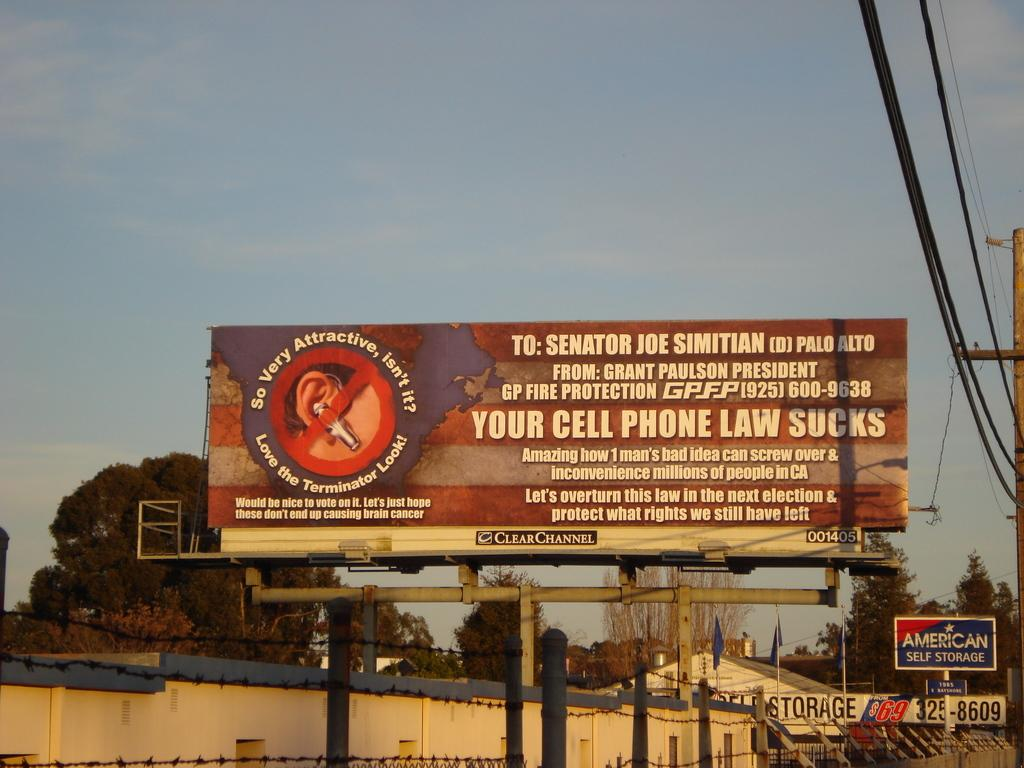<image>
Give a short and clear explanation of the subsequent image. A billboard offending Senator Joe Simitian sits above an American Storage sign 